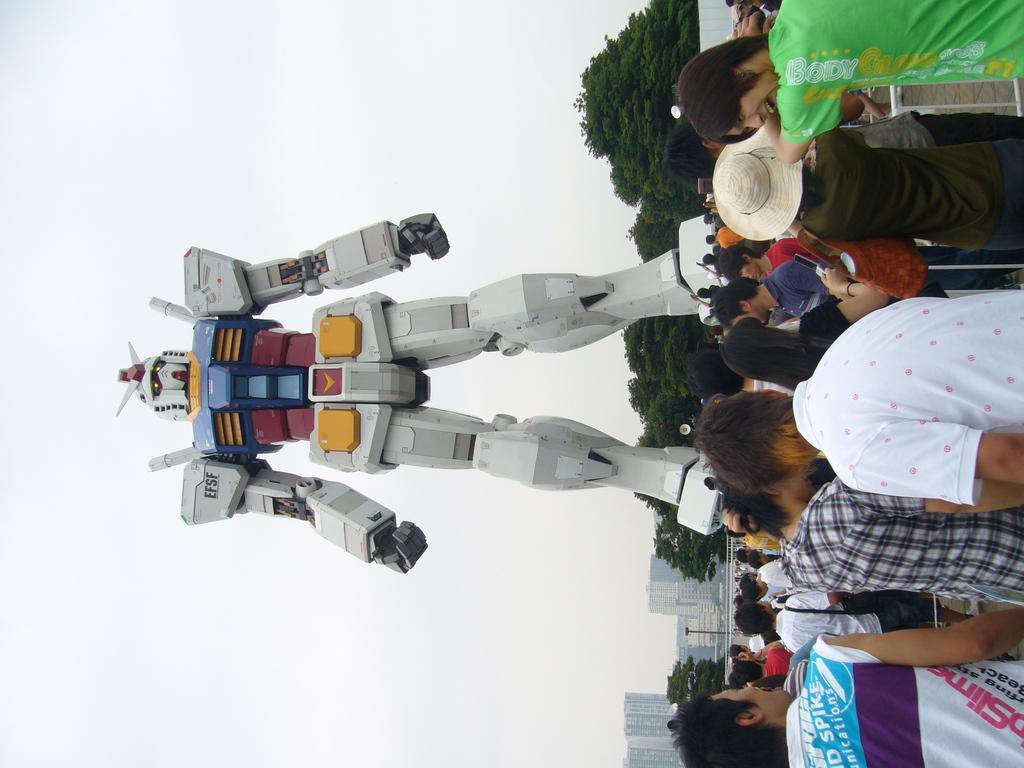Can you describe this image briefly? In this image we can see a robot. Behind the robot we can see a group of trees, buildings and the sky. On the right side, we can see a group of persons. 